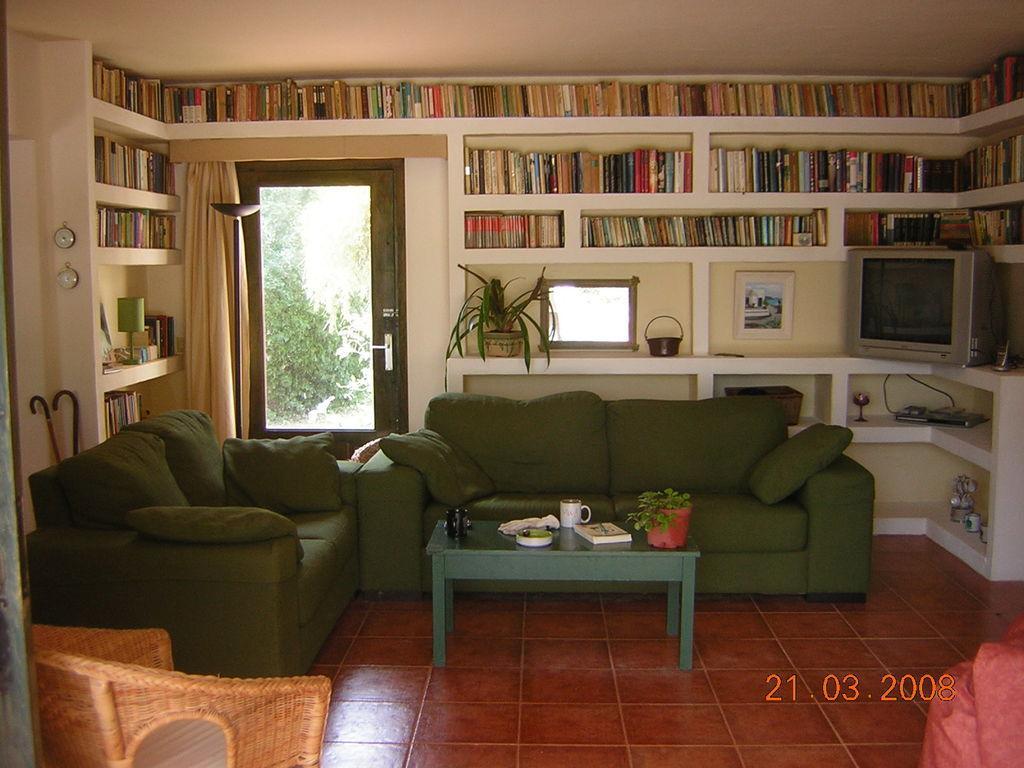In one or two sentences, can you explain what this image depicts? There is a green sofa which has a green table in front of it and there is a bookshelf,television and a door in the background. 